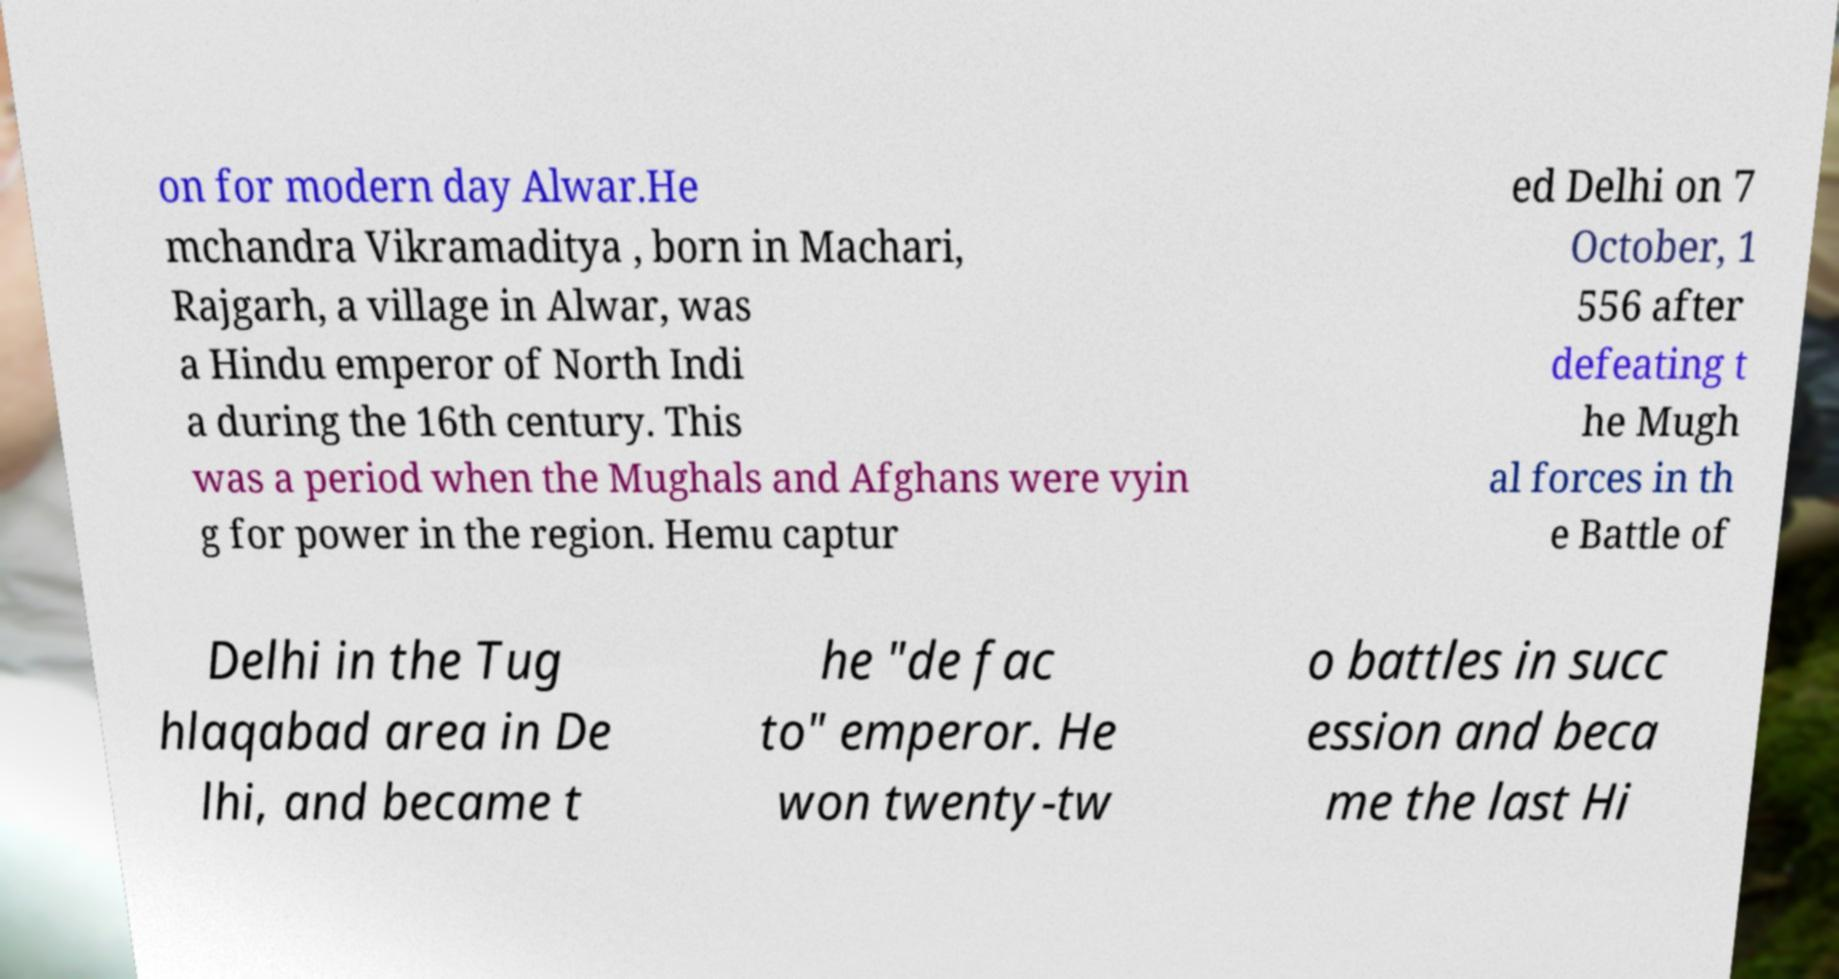I need the written content from this picture converted into text. Can you do that? on for modern day Alwar.He mchandra Vikramaditya , born in Machari, Rajgarh, a village in Alwar, was a Hindu emperor of North Indi a during the 16th century. This was a period when the Mughals and Afghans were vyin g for power in the region. Hemu captur ed Delhi on 7 October, 1 556 after defeating t he Mugh al forces in th e Battle of Delhi in the Tug hlaqabad area in De lhi, and became t he "de fac to" emperor. He won twenty-tw o battles in succ ession and beca me the last Hi 